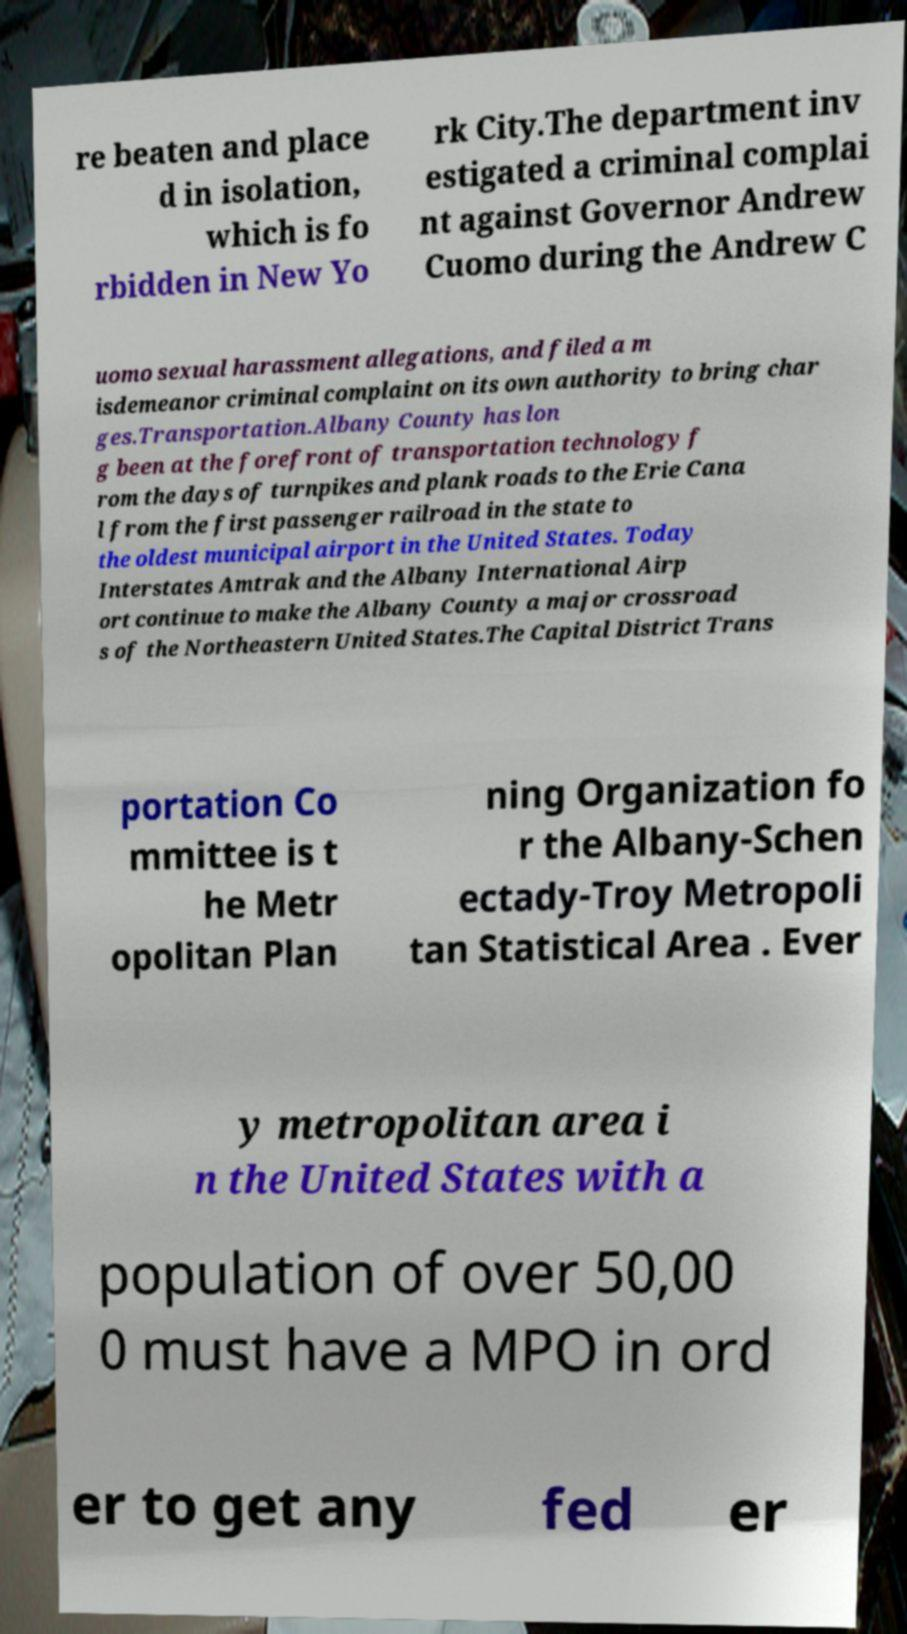I need the written content from this picture converted into text. Can you do that? re beaten and place d in isolation, which is fo rbidden in New Yo rk City.The department inv estigated a criminal complai nt against Governor Andrew Cuomo during the Andrew C uomo sexual harassment allegations, and filed a m isdemeanor criminal complaint on its own authority to bring char ges.Transportation.Albany County has lon g been at the forefront of transportation technology f rom the days of turnpikes and plank roads to the Erie Cana l from the first passenger railroad in the state to the oldest municipal airport in the United States. Today Interstates Amtrak and the Albany International Airp ort continue to make the Albany County a major crossroad s of the Northeastern United States.The Capital District Trans portation Co mmittee is t he Metr opolitan Plan ning Organization fo r the Albany-Schen ectady-Troy Metropoli tan Statistical Area . Ever y metropolitan area i n the United States with a population of over 50,00 0 must have a MPO in ord er to get any fed er 